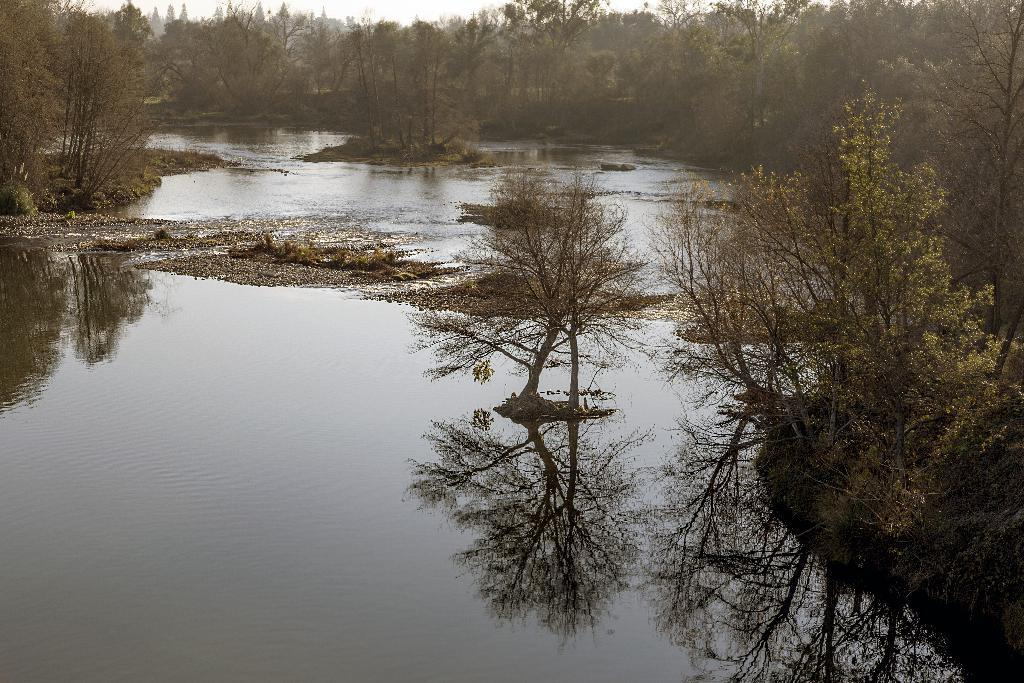What is located on the left side of the image? There is water on the left side of the image. What can be seen on the right side of the image? There are trees on the ground on the right side of the image. What is visible in the background of the image? There are trees visible in the background of the image. How many friends are visible in the image? There are no friends present in the image. Is there a servant carrying bricks in the image? There is no servant or bricks present in the image. 